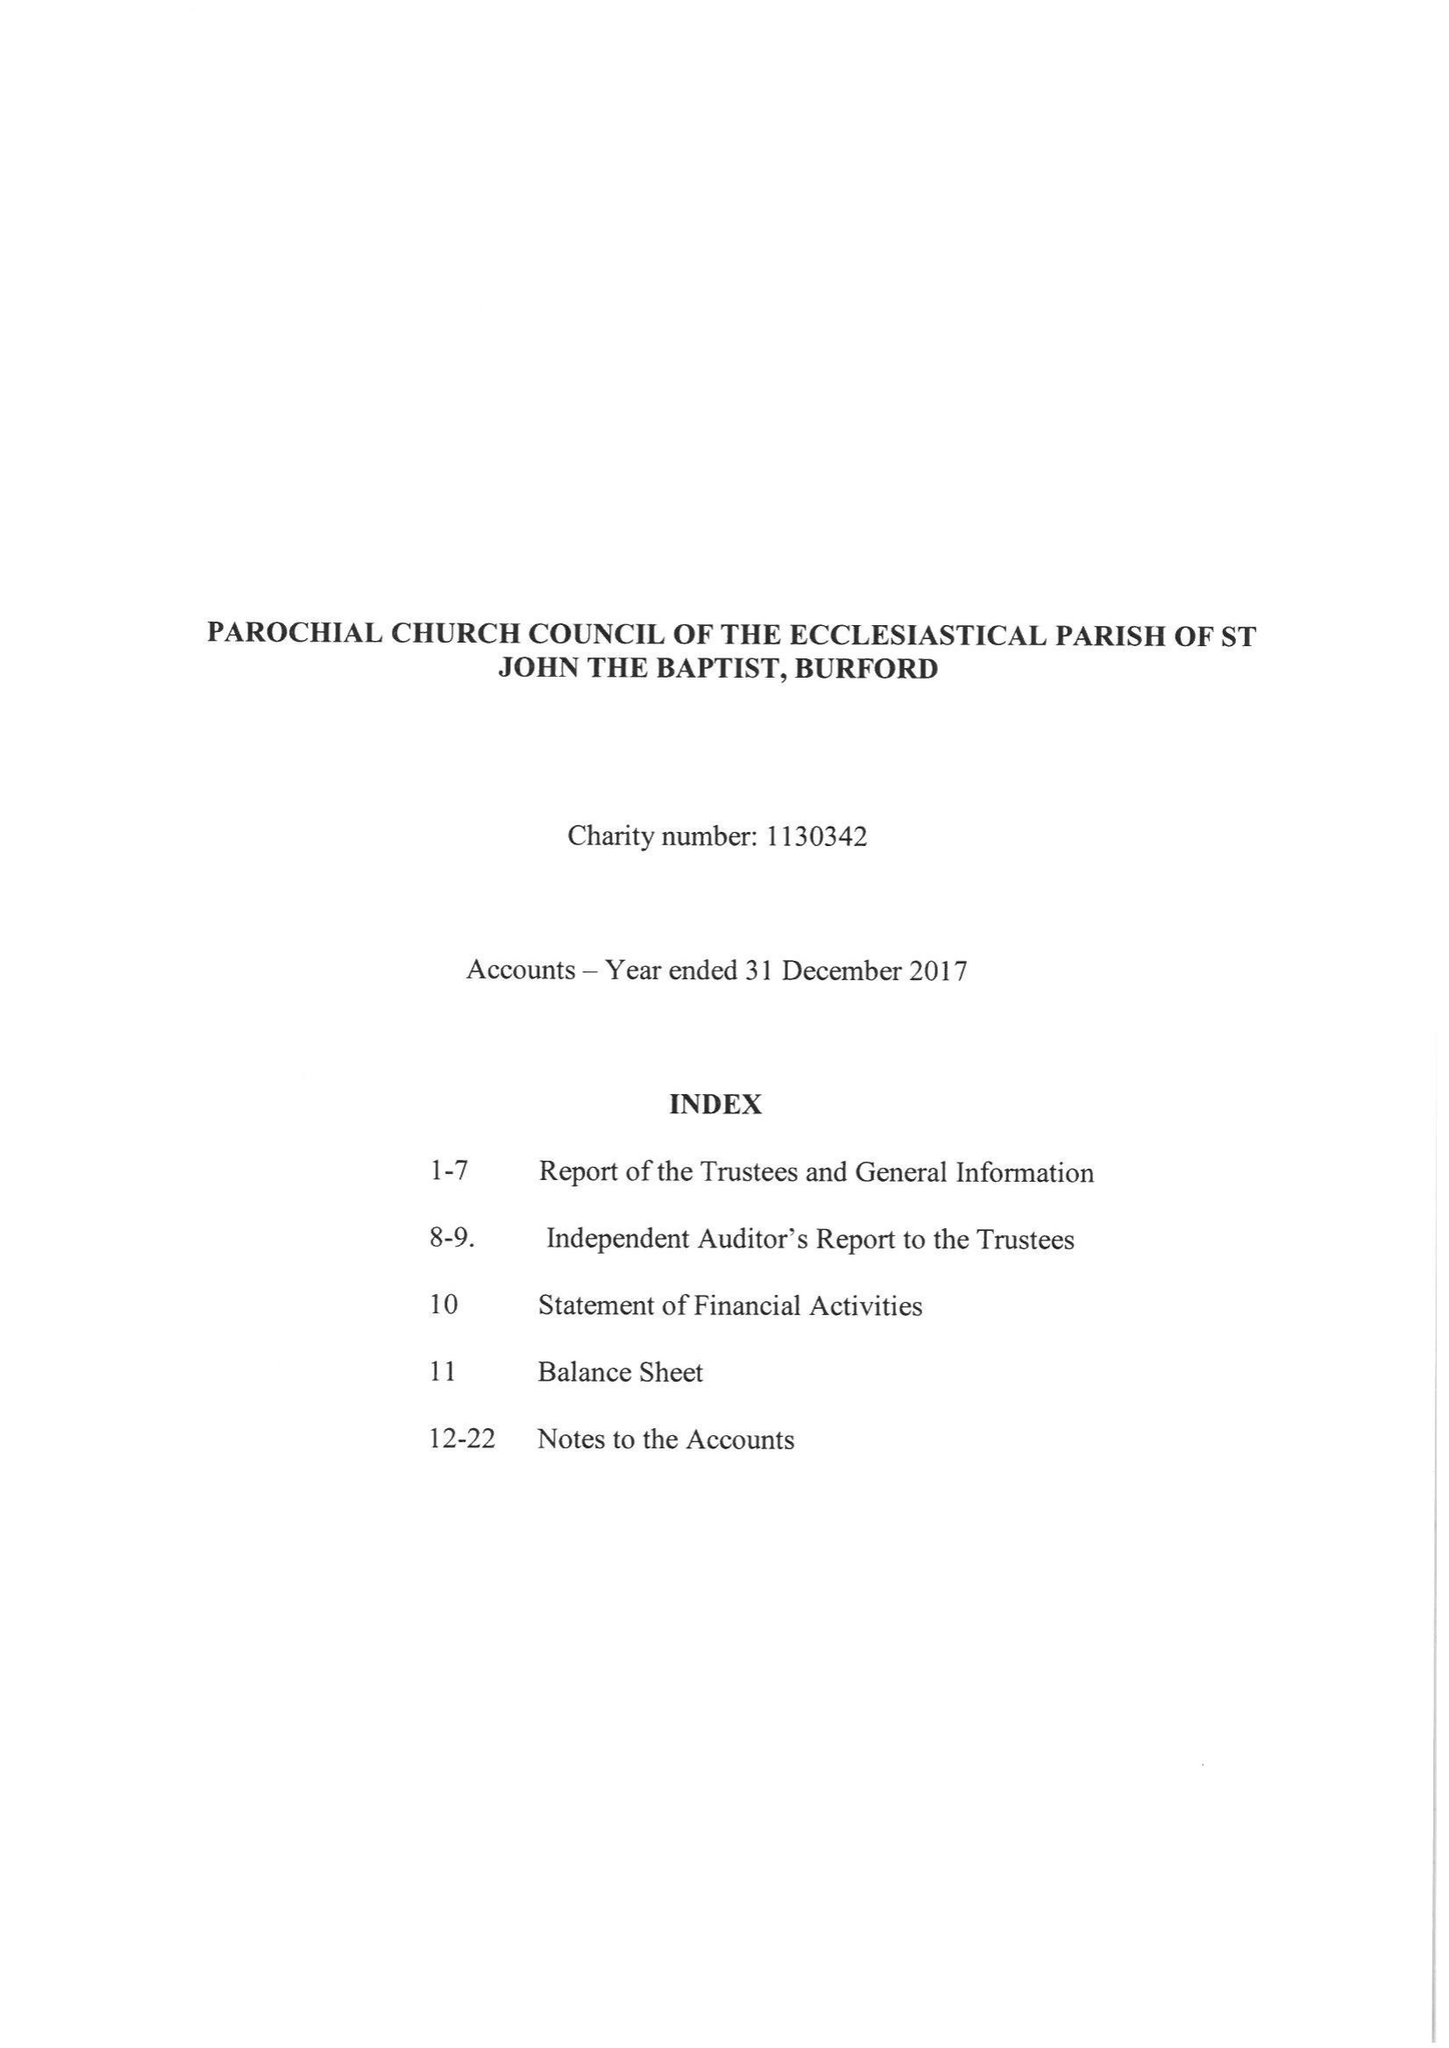What is the value for the report_date?
Answer the question using a single word or phrase. 2017-12-31 